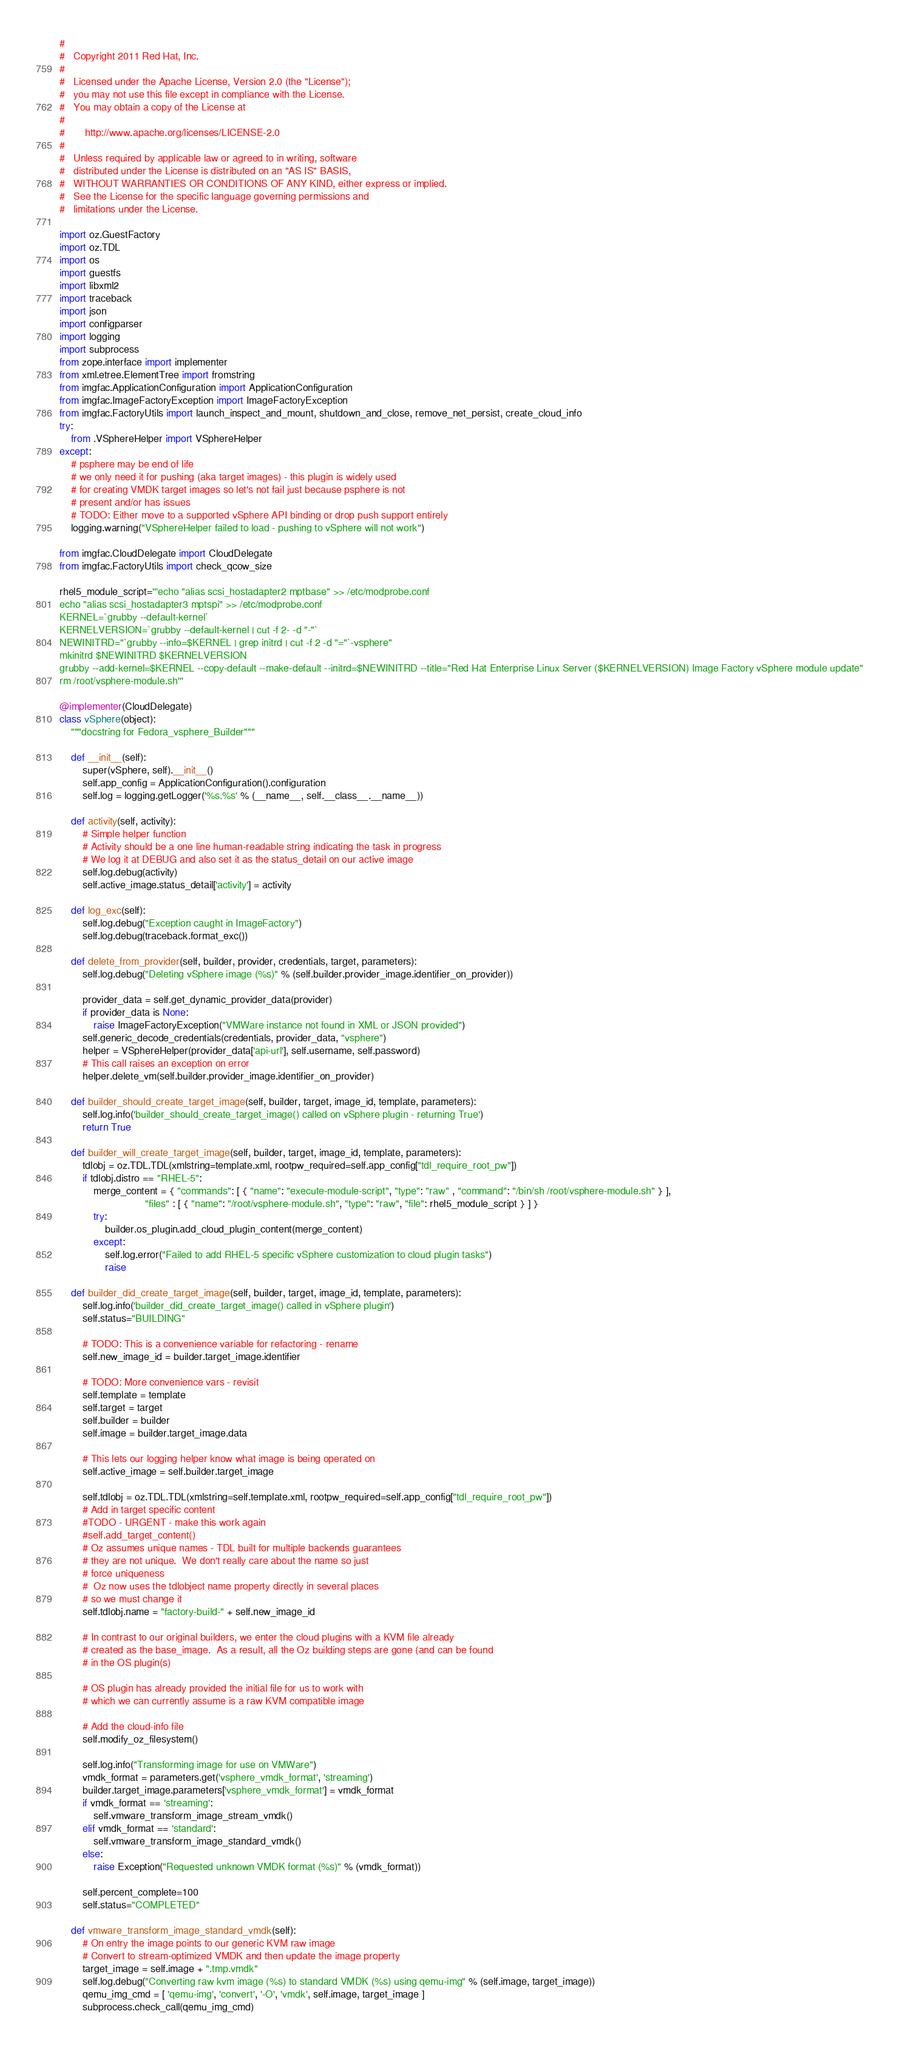<code> <loc_0><loc_0><loc_500><loc_500><_Python_>#
#   Copyright 2011 Red Hat, Inc.
#
#   Licensed under the Apache License, Version 2.0 (the "License");
#   you may not use this file except in compliance with the License.
#   You may obtain a copy of the License at
#
#       http://www.apache.org/licenses/LICENSE-2.0
#
#   Unless required by applicable law or agreed to in writing, software
#   distributed under the License is distributed on an "AS IS" BASIS,
#   WITHOUT WARRANTIES OR CONDITIONS OF ANY KIND, either express or implied.
#   See the License for the specific language governing permissions and
#   limitations under the License.

import oz.GuestFactory
import oz.TDL
import os
import guestfs
import libxml2
import traceback
import json
import configparser
import logging
import subprocess
from zope.interface import implementer
from xml.etree.ElementTree import fromstring
from imgfac.ApplicationConfiguration import ApplicationConfiguration
from imgfac.ImageFactoryException import ImageFactoryException
from imgfac.FactoryUtils import launch_inspect_and_mount, shutdown_and_close, remove_net_persist, create_cloud_info
try:
    from .VSphereHelper import VSphereHelper
except:
    # psphere may be end of life
    # we only need it for pushing (aka target images) - this plugin is widely used
    # for creating VMDK target images so let's not fail just because psphere is not
    # present and/or has issues
    # TODO: Either move to a supported vSphere API binding or drop push support entirely
    logging.warning("VSphereHelper failed to load - pushing to vSphere will not work")

from imgfac.CloudDelegate import CloudDelegate
from imgfac.FactoryUtils import check_qcow_size

rhel5_module_script='''echo "alias scsi_hostadapter2 mptbase" >> /etc/modprobe.conf
echo "alias scsi_hostadapter3 mptspi" >> /etc/modprobe.conf
KERNEL=`grubby --default-kernel`
KERNELVERSION=`grubby --default-kernel | cut -f 2- -d "-"`
NEWINITRD="`grubby --info=$KERNEL | grep initrd | cut -f 2 -d "="`-vsphere"
mkinitrd $NEWINITRD $KERNELVERSION
grubby --add-kernel=$KERNEL --copy-default --make-default --initrd=$NEWINITRD --title="Red Hat Enterprise Linux Server ($KERNELVERSION) Image Factory vSphere module update"
rm /root/vsphere-module.sh'''

@implementer(CloudDelegate)
class vSphere(object):
    """docstring for Fedora_vsphere_Builder"""

    def __init__(self):
        super(vSphere, self).__init__()
        self.app_config = ApplicationConfiguration().configuration
        self.log = logging.getLogger('%s.%s' % (__name__, self.__class__.__name__))

    def activity(self, activity):
        # Simple helper function
        # Activity should be a one line human-readable string indicating the task in progress
        # We log it at DEBUG and also set it as the status_detail on our active image
        self.log.debug(activity)
        self.active_image.status_detail['activity'] = activity

    def log_exc(self):
        self.log.debug("Exception caught in ImageFactory")
        self.log.debug(traceback.format_exc())

    def delete_from_provider(self, builder, provider, credentials, target, parameters):
        self.log.debug("Deleting vSphere image (%s)" % (self.builder.provider_image.identifier_on_provider))

        provider_data = self.get_dynamic_provider_data(provider)
        if provider_data is None:
            raise ImageFactoryException("VMWare instance not found in XML or JSON provided")
        self.generic_decode_credentials(credentials, provider_data, "vsphere")
        helper = VSphereHelper(provider_data['api-url'], self.username, self.password)
        # This call raises an exception on error
        helper.delete_vm(self.builder.provider_image.identifier_on_provider)

    def builder_should_create_target_image(self, builder, target, image_id, template, parameters):
        self.log.info('builder_should_create_target_image() called on vSphere plugin - returning True')
        return True

    def builder_will_create_target_image(self, builder, target, image_id, template, parameters):
        tdlobj = oz.TDL.TDL(xmlstring=template.xml, rootpw_required=self.app_config["tdl_require_root_pw"])
        if tdlobj.distro == "RHEL-5":
            merge_content = { "commands": [ { "name": "execute-module-script", "type": "raw" , "command": "/bin/sh /root/vsphere-module.sh" } ],
                              "files" : [ { "name": "/root/vsphere-module.sh", "type": "raw", "file": rhel5_module_script } ] }
            try:
                builder.os_plugin.add_cloud_plugin_content(merge_content)
            except:
                self.log.error("Failed to add RHEL-5 specific vSphere customization to cloud plugin tasks")
                raise

    def builder_did_create_target_image(self, builder, target, image_id, template, parameters):
        self.log.info('builder_did_create_target_image() called in vSphere plugin')
        self.status="BUILDING"

        # TODO: This is a convenience variable for refactoring - rename
        self.new_image_id = builder.target_image.identifier

        # TODO: More convenience vars - revisit
        self.template = template
        self.target = target
        self.builder = builder
        self.image = builder.target_image.data

        # This lets our logging helper know what image is being operated on
        self.active_image = self.builder.target_image

        self.tdlobj = oz.TDL.TDL(xmlstring=self.template.xml, rootpw_required=self.app_config["tdl_require_root_pw"])
        # Add in target specific content
        #TODO - URGENT - make this work again
        #self.add_target_content()
        # Oz assumes unique names - TDL built for multiple backends guarantees
        # they are not unique.  We don't really care about the name so just
        # force uniqueness
        #  Oz now uses the tdlobject name property directly in several places
        # so we must change it
        self.tdlobj.name = "factory-build-" + self.new_image_id

        # In contrast to our original builders, we enter the cloud plugins with a KVM file already
        # created as the base_image.  As a result, all the Oz building steps are gone (and can be found
        # in the OS plugin(s)

        # OS plugin has already provided the initial file for us to work with
        # which we can currently assume is a raw KVM compatible image

        # Add the cloud-info file
        self.modify_oz_filesystem()

        self.log.info("Transforming image for use on VMWare")
        vmdk_format = parameters.get('vsphere_vmdk_format', 'streaming')
        builder.target_image.parameters['vsphere_vmdk_format'] = vmdk_format
        if vmdk_format == 'streaming':
            self.vmware_transform_image_stream_vmdk()
        elif vmdk_format == 'standard':
            self.vmware_transform_image_standard_vmdk()
        else:
            raise Exception("Requested unknown VMDK format (%s)" % (vmdk_format))

        self.percent_complete=100
        self.status="COMPLETED"

    def vmware_transform_image_standard_vmdk(self):
        # On entry the image points to our generic KVM raw image
        # Convert to stream-optimized VMDK and then update the image property
        target_image = self.image + ".tmp.vmdk"
        self.log.debug("Converting raw kvm image (%s) to standard VMDK (%s) using qemu-img" % (self.image, target_image))
        qemu_img_cmd = [ 'qemu-img', 'convert', '-O', 'vmdk', self.image, target_image ]
        subprocess.check_call(qemu_img_cmd)</code> 